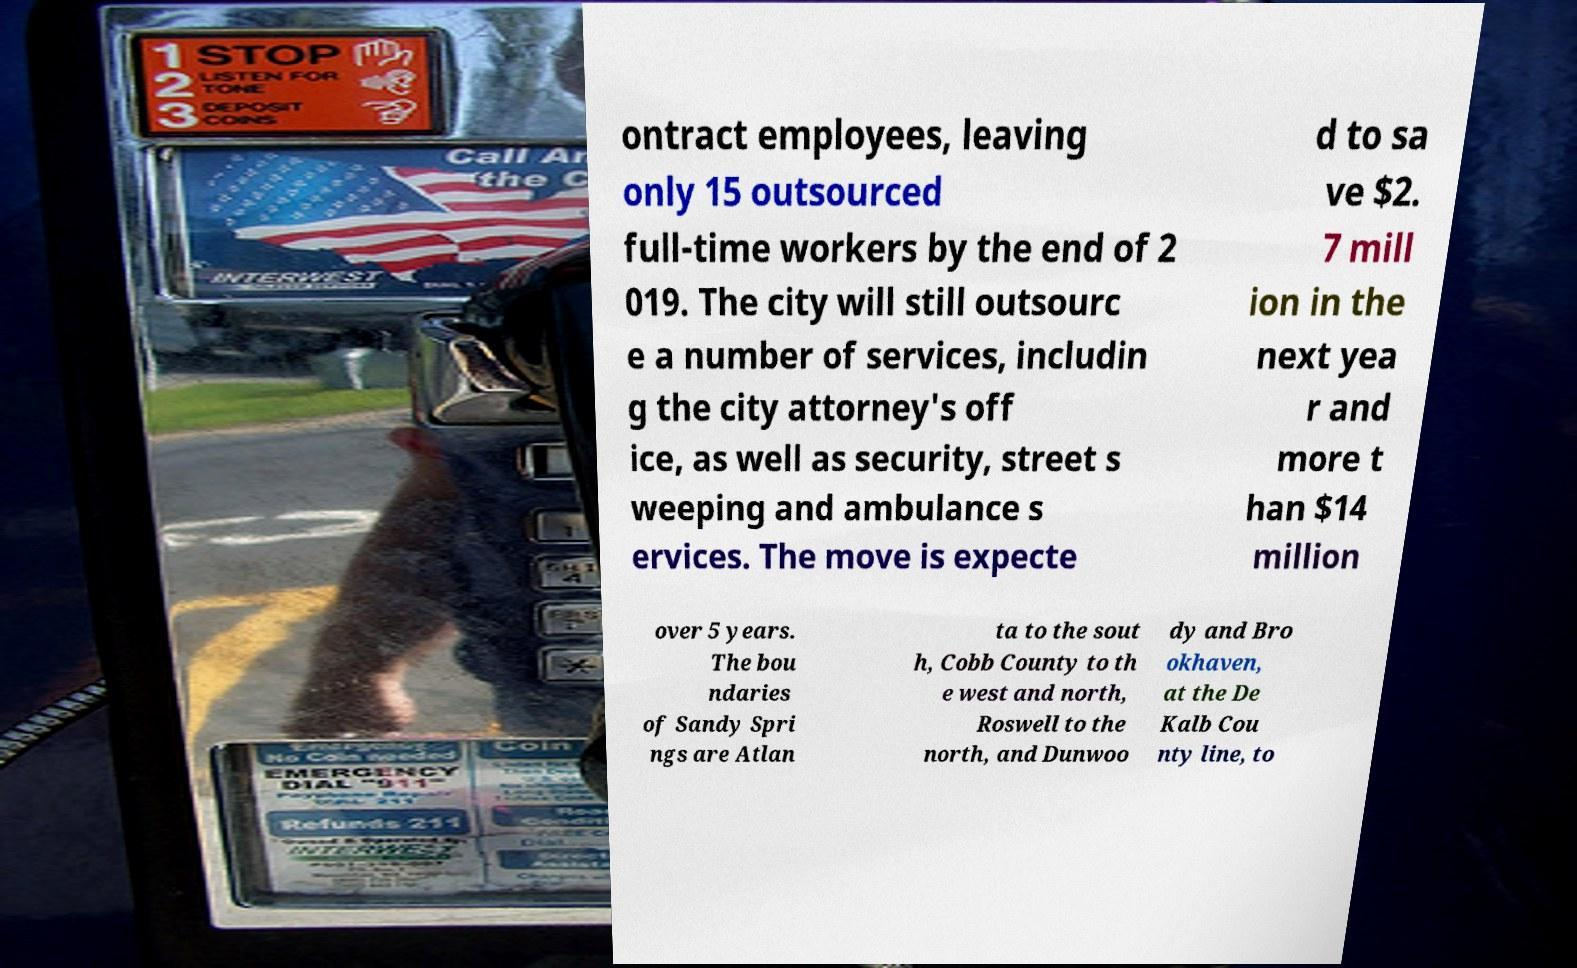Could you extract and type out the text from this image? ontract employees, leaving only 15 outsourced full-time workers by the end of 2 019. The city will still outsourc e a number of services, includin g the city attorney's off ice, as well as security, street s weeping and ambulance s ervices. The move is expecte d to sa ve $2. 7 mill ion in the next yea r and more t han $14 million over 5 years. The bou ndaries of Sandy Spri ngs are Atlan ta to the sout h, Cobb County to th e west and north, Roswell to the north, and Dunwoo dy and Bro okhaven, at the De Kalb Cou nty line, to 